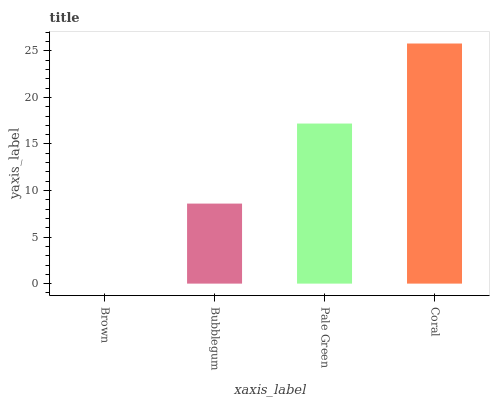Is Brown the minimum?
Answer yes or no. Yes. Is Coral the maximum?
Answer yes or no. Yes. Is Bubblegum the minimum?
Answer yes or no. No. Is Bubblegum the maximum?
Answer yes or no. No. Is Bubblegum greater than Brown?
Answer yes or no. Yes. Is Brown less than Bubblegum?
Answer yes or no. Yes. Is Brown greater than Bubblegum?
Answer yes or no. No. Is Bubblegum less than Brown?
Answer yes or no. No. Is Pale Green the high median?
Answer yes or no. Yes. Is Bubblegum the low median?
Answer yes or no. Yes. Is Coral the high median?
Answer yes or no. No. Is Pale Green the low median?
Answer yes or no. No. 